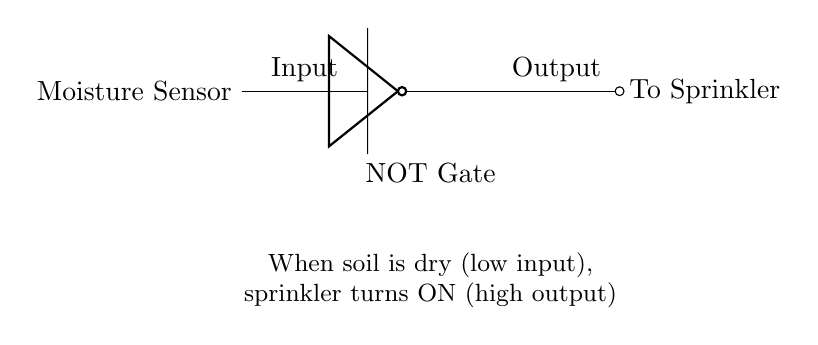What is the key component in this circuit? The key component in this circuit is the NOT gate, which inverts the input signal from the moisture sensor. It is crucial for controlling the sprinkler based on soil moisture levels.
Answer: NOT gate What does the moisture sensor detect? The moisture sensor detects soil moisture levels, providing an input signal that indicates whether the soil is dry or wet, which is essential for automatic watering.
Answer: Soil moisture What is the output of the NOT gate when the input is high? When the input to the NOT gate is high, the output will be low, which indicates that the sprinkler will not turn on when the soil is moist.
Answer: Low How does the NOT gate affect the sprinkler operation? The NOT gate inverts the moisture sensor's signal; if the soil is dry (low input), it outputs high to turn on the sprinkler. Thus, the sprinkler operates when the soil moisture is insufficient.
Answer: The sprinkler turns on What happens when the soil is wet? When the soil is wet, the moisture sensor sends a high input. The NOT gate will output low, preventing the sprinkler from activating, thus conserving water.
Answer: Sprinkler off What is the purpose of the NOT gate in this circuit? The purpose of the NOT gate is to invert the moisture sensor's signal, ensuring the sprinkler operates only when the soil is dry, thus providing efficient irrigation.
Answer: To control sprinkler based on moisture 